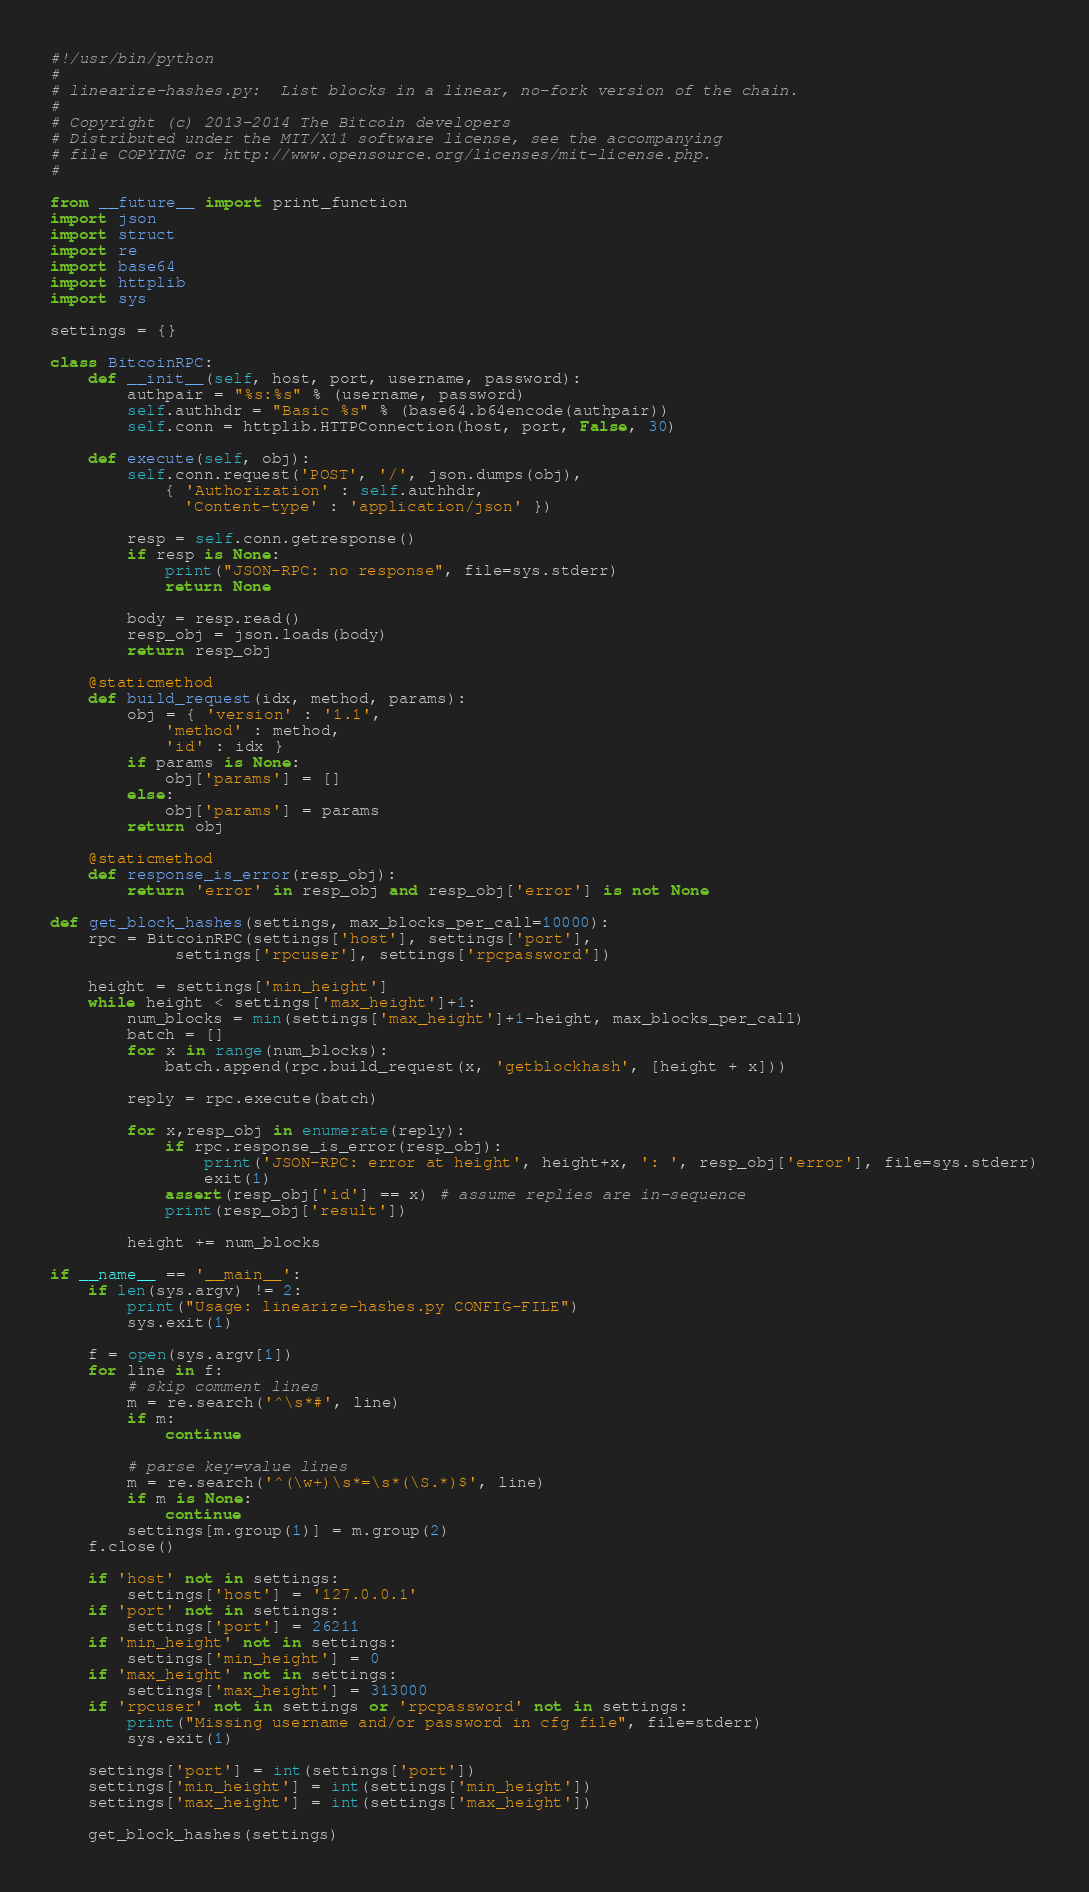Convert code to text. <code><loc_0><loc_0><loc_500><loc_500><_Python_>#!/usr/bin/python
#
# linearize-hashes.py:  List blocks in a linear, no-fork version of the chain.
#
# Copyright (c) 2013-2014 The Bitcoin developers
# Distributed under the MIT/X11 software license, see the accompanying
# file COPYING or http://www.opensource.org/licenses/mit-license.php.
#

from __future__ import print_function
import json
import struct
import re
import base64
import httplib
import sys

settings = {}

class BitcoinRPC:
	def __init__(self, host, port, username, password):
		authpair = "%s:%s" % (username, password)
		self.authhdr = "Basic %s" % (base64.b64encode(authpair))
		self.conn = httplib.HTTPConnection(host, port, False, 30)

	def execute(self, obj):
		self.conn.request('POST', '/', json.dumps(obj),
			{ 'Authorization' : self.authhdr,
			  'Content-type' : 'application/json' })

		resp = self.conn.getresponse()
		if resp is None:
			print("JSON-RPC: no response", file=sys.stderr)
			return None

		body = resp.read()
		resp_obj = json.loads(body)
		return resp_obj

	@staticmethod
	def build_request(idx, method, params):
		obj = { 'version' : '1.1',
			'method' : method,
			'id' : idx }
		if params is None:
			obj['params'] = []
		else:
			obj['params'] = params
		return obj

	@staticmethod
	def response_is_error(resp_obj):
		return 'error' in resp_obj and resp_obj['error'] is not None

def get_block_hashes(settings, max_blocks_per_call=10000):
	rpc = BitcoinRPC(settings['host'], settings['port'],
			 settings['rpcuser'], settings['rpcpassword'])

	height = settings['min_height']
	while height < settings['max_height']+1:
		num_blocks = min(settings['max_height']+1-height, max_blocks_per_call)
		batch = []
		for x in range(num_blocks):
			batch.append(rpc.build_request(x, 'getblockhash', [height + x]))

		reply = rpc.execute(batch)

		for x,resp_obj in enumerate(reply):
			if rpc.response_is_error(resp_obj):
				print('JSON-RPC: error at height', height+x, ': ', resp_obj['error'], file=sys.stderr)
				exit(1)
			assert(resp_obj['id'] == x) # assume replies are in-sequence
			print(resp_obj['result'])

		height += num_blocks

if __name__ == '__main__':
	if len(sys.argv) != 2:
		print("Usage: linearize-hashes.py CONFIG-FILE")
		sys.exit(1)

	f = open(sys.argv[1])
	for line in f:
		# skip comment lines
		m = re.search('^\s*#', line)
		if m:
			continue

		# parse key=value lines
		m = re.search('^(\w+)\s*=\s*(\S.*)$', line)
		if m is None:
			continue
		settings[m.group(1)] = m.group(2)
	f.close()

	if 'host' not in settings:
		settings['host'] = '127.0.0.1'
	if 'port' not in settings:
		settings['port'] = 26211
	if 'min_height' not in settings:
		settings['min_height'] = 0
	if 'max_height' not in settings:
		settings['max_height'] = 313000
	if 'rpcuser' not in settings or 'rpcpassword' not in settings:
		print("Missing username and/or password in cfg file", file=stderr)
		sys.exit(1)

	settings['port'] = int(settings['port'])
	settings['min_height'] = int(settings['min_height'])
	settings['max_height'] = int(settings['max_height'])

	get_block_hashes(settings)

</code> 